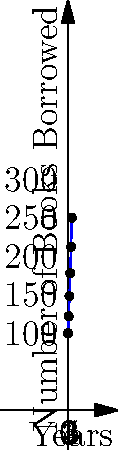The graph shows the number of books borrowed from a library over a 5-year period. If this trend continues, how many more books will be borrowed in Year 6 compared to Year 5? To solve this problem, we need to follow these steps:

1. Identify the pattern in the graph:
   The curve appears to be quadratic, suggesting a function of the form $f(x) = ax^2 + bx + c$.

2. Calculate the number of books borrowed in Year 5:
   $f(5) = 100 + 20(5) + 2(5)^2 = 100 + 100 + 50 = 250$ books

3. Calculate the number of books borrowed in Year 6:
   $f(6) = 100 + 20(6) + 2(6)^2 = 100 + 120 + 72 = 292$ books

4. Find the difference between Year 6 and Year 5:
   $292 - 250 = 42$ books

Therefore, 42 more books will be borrowed in Year 6 compared to Year 5 if the trend continues.
Answer: 42 books 